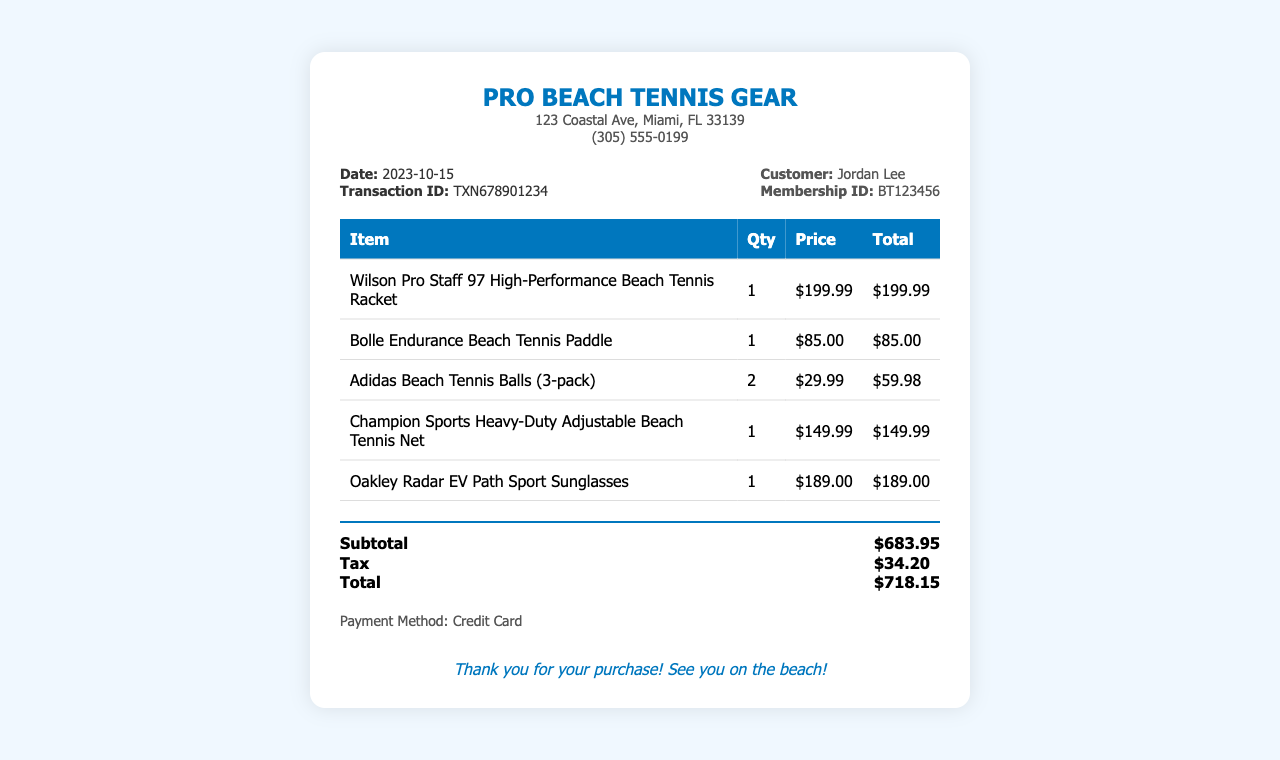What is the date of the purchase? The date of purchase is stated in the receipt details.
Answer: 2023-10-15 What is the name of the store? The store name is prominently displayed at the top of the receipt.
Answer: Pro Beach Tennis Gear What is the total amount paid? The total amount is summarized in the total section of the receipt.
Answer: $718.15 How many Adidas Beach Tennis Balls were purchased? The quantity of Adidas Beach Tennis Balls is indicated in the itemized list.
Answer: 2 What was the payment method used? The payment method is specified in the payment info section of the receipt.
Answer: Credit Card What is the membership ID of the customer? The customer’s membership ID is provided in the customer info section.
Answer: BT123456 What is the price of the Wilson Pro Staff 97 racket? The price of the racket is included in the itemized pricing for that item.
Answer: $199.99 How much was the tax on the total purchase? The tax amount is detailed in the total section of the receipt.
Answer: $34.20 What item is listed as the most expensive? The pricing indicates which item has the highest cost in the list.
Answer: Wilson Pro Staff 97 High-Performance Beach Tennis Racket 